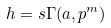<formula> <loc_0><loc_0><loc_500><loc_500>h = s \Gamma ( a , p ^ { m } )</formula> 